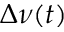Convert formula to latex. <formula><loc_0><loc_0><loc_500><loc_500>\Delta \nu ( t )</formula> 